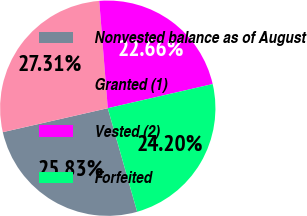Convert chart to OTSL. <chart><loc_0><loc_0><loc_500><loc_500><pie_chart><fcel>Nonvested balance as of August<fcel>Granted (1)<fcel>Vested (2)<fcel>Forfeited<nl><fcel>25.83%<fcel>27.31%<fcel>22.66%<fcel>24.2%<nl></chart> 